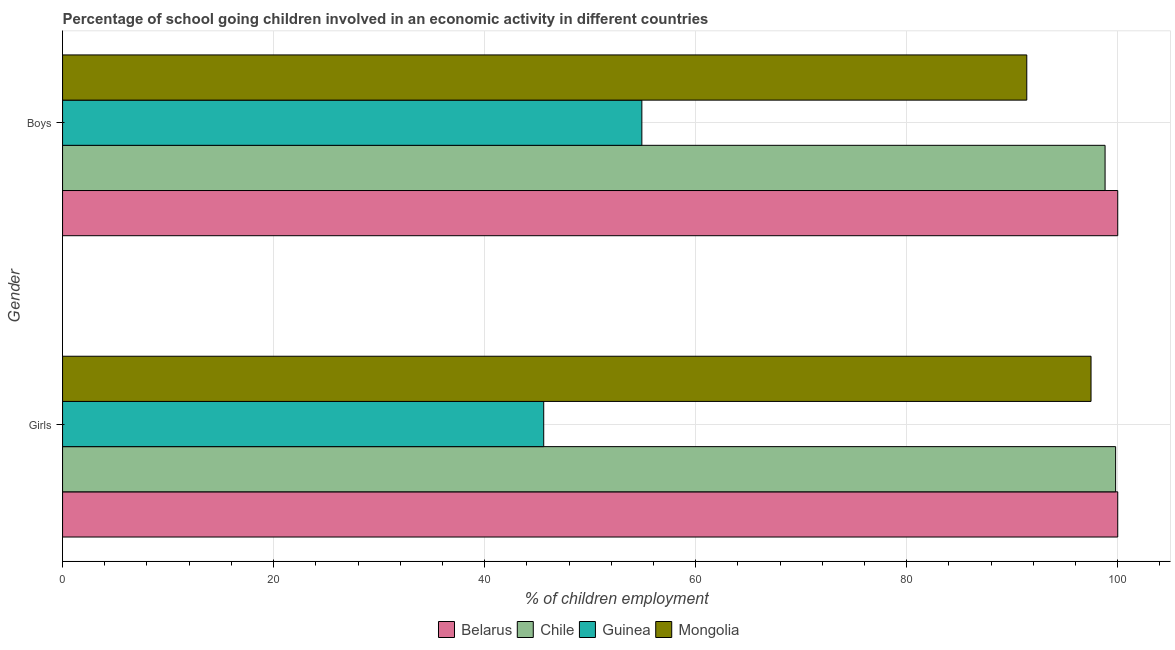How many different coloured bars are there?
Offer a terse response. 4. Are the number of bars on each tick of the Y-axis equal?
Offer a very short reply. Yes. How many bars are there on the 2nd tick from the top?
Offer a terse response. 4. How many bars are there on the 1st tick from the bottom?
Make the answer very short. 4. What is the label of the 2nd group of bars from the top?
Offer a terse response. Girls. What is the percentage of school going girls in Guinea?
Your response must be concise. 45.6. Across all countries, what is the minimum percentage of school going girls?
Make the answer very short. 45.6. In which country was the percentage of school going girls maximum?
Offer a very short reply. Belarus. In which country was the percentage of school going boys minimum?
Your answer should be very brief. Guinea. What is the total percentage of school going girls in the graph?
Offer a very short reply. 342.87. What is the difference between the percentage of school going girls in Belarus and that in Chile?
Your response must be concise. 0.2. What is the difference between the percentage of school going girls in Mongolia and the percentage of school going boys in Guinea?
Provide a succinct answer. 42.57. What is the average percentage of school going girls per country?
Provide a short and direct response. 85.72. What is the difference between the percentage of school going girls and percentage of school going boys in Guinea?
Your answer should be compact. -9.3. What is the ratio of the percentage of school going girls in Belarus to that in Mongolia?
Keep it short and to the point. 1.03. What does the 1st bar from the top in Boys represents?
Offer a very short reply. Mongolia. What does the 3rd bar from the bottom in Boys represents?
Your answer should be very brief. Guinea. How many bars are there?
Provide a short and direct response. 8. Are all the bars in the graph horizontal?
Ensure brevity in your answer.  Yes. How many countries are there in the graph?
Make the answer very short. 4. Are the values on the major ticks of X-axis written in scientific E-notation?
Provide a succinct answer. No. Does the graph contain any zero values?
Ensure brevity in your answer.  No. Does the graph contain grids?
Give a very brief answer. Yes. What is the title of the graph?
Offer a very short reply. Percentage of school going children involved in an economic activity in different countries. What is the label or title of the X-axis?
Offer a very short reply. % of children employment. What is the % of children employment of Chile in Girls?
Make the answer very short. 99.8. What is the % of children employment of Guinea in Girls?
Your response must be concise. 45.6. What is the % of children employment of Mongolia in Girls?
Your answer should be very brief. 97.47. What is the % of children employment in Chile in Boys?
Your response must be concise. 98.8. What is the % of children employment in Guinea in Boys?
Make the answer very short. 54.9. What is the % of children employment of Mongolia in Boys?
Your response must be concise. 91.38. Across all Gender, what is the maximum % of children employment of Belarus?
Make the answer very short. 100. Across all Gender, what is the maximum % of children employment of Chile?
Keep it short and to the point. 99.8. Across all Gender, what is the maximum % of children employment of Guinea?
Offer a very short reply. 54.9. Across all Gender, what is the maximum % of children employment of Mongolia?
Offer a very short reply. 97.47. Across all Gender, what is the minimum % of children employment in Belarus?
Your answer should be compact. 100. Across all Gender, what is the minimum % of children employment of Chile?
Provide a succinct answer. 98.8. Across all Gender, what is the minimum % of children employment in Guinea?
Keep it short and to the point. 45.6. Across all Gender, what is the minimum % of children employment of Mongolia?
Ensure brevity in your answer.  91.38. What is the total % of children employment in Belarus in the graph?
Provide a short and direct response. 200. What is the total % of children employment in Chile in the graph?
Your answer should be very brief. 198.6. What is the total % of children employment in Guinea in the graph?
Ensure brevity in your answer.  100.5. What is the total % of children employment of Mongolia in the graph?
Your response must be concise. 188.85. What is the difference between the % of children employment of Guinea in Girls and that in Boys?
Make the answer very short. -9.3. What is the difference between the % of children employment of Mongolia in Girls and that in Boys?
Ensure brevity in your answer.  6.09. What is the difference between the % of children employment of Belarus in Girls and the % of children employment of Chile in Boys?
Offer a very short reply. 1.2. What is the difference between the % of children employment in Belarus in Girls and the % of children employment in Guinea in Boys?
Provide a short and direct response. 45.1. What is the difference between the % of children employment in Belarus in Girls and the % of children employment in Mongolia in Boys?
Your answer should be compact. 8.62. What is the difference between the % of children employment in Chile in Girls and the % of children employment in Guinea in Boys?
Your answer should be very brief. 44.9. What is the difference between the % of children employment in Chile in Girls and the % of children employment in Mongolia in Boys?
Your answer should be very brief. 8.42. What is the difference between the % of children employment of Guinea in Girls and the % of children employment of Mongolia in Boys?
Offer a terse response. -45.78. What is the average % of children employment in Chile per Gender?
Provide a succinct answer. 99.3. What is the average % of children employment of Guinea per Gender?
Your response must be concise. 50.25. What is the average % of children employment of Mongolia per Gender?
Your answer should be very brief. 94.42. What is the difference between the % of children employment in Belarus and % of children employment in Chile in Girls?
Your answer should be compact. 0.2. What is the difference between the % of children employment in Belarus and % of children employment in Guinea in Girls?
Provide a succinct answer. 54.4. What is the difference between the % of children employment of Belarus and % of children employment of Mongolia in Girls?
Your answer should be very brief. 2.53. What is the difference between the % of children employment of Chile and % of children employment of Guinea in Girls?
Give a very brief answer. 54.2. What is the difference between the % of children employment in Chile and % of children employment in Mongolia in Girls?
Make the answer very short. 2.33. What is the difference between the % of children employment of Guinea and % of children employment of Mongolia in Girls?
Make the answer very short. -51.87. What is the difference between the % of children employment in Belarus and % of children employment in Guinea in Boys?
Make the answer very short. 45.1. What is the difference between the % of children employment of Belarus and % of children employment of Mongolia in Boys?
Keep it short and to the point. 8.62. What is the difference between the % of children employment of Chile and % of children employment of Guinea in Boys?
Make the answer very short. 43.9. What is the difference between the % of children employment in Chile and % of children employment in Mongolia in Boys?
Provide a short and direct response. 7.42. What is the difference between the % of children employment in Guinea and % of children employment in Mongolia in Boys?
Offer a terse response. -36.48. What is the ratio of the % of children employment in Guinea in Girls to that in Boys?
Provide a succinct answer. 0.83. What is the ratio of the % of children employment of Mongolia in Girls to that in Boys?
Keep it short and to the point. 1.07. What is the difference between the highest and the second highest % of children employment in Belarus?
Give a very brief answer. 0. What is the difference between the highest and the second highest % of children employment of Chile?
Offer a terse response. 1. What is the difference between the highest and the second highest % of children employment in Guinea?
Ensure brevity in your answer.  9.3. What is the difference between the highest and the second highest % of children employment in Mongolia?
Ensure brevity in your answer.  6.09. What is the difference between the highest and the lowest % of children employment in Belarus?
Your answer should be very brief. 0. What is the difference between the highest and the lowest % of children employment of Mongolia?
Make the answer very short. 6.09. 